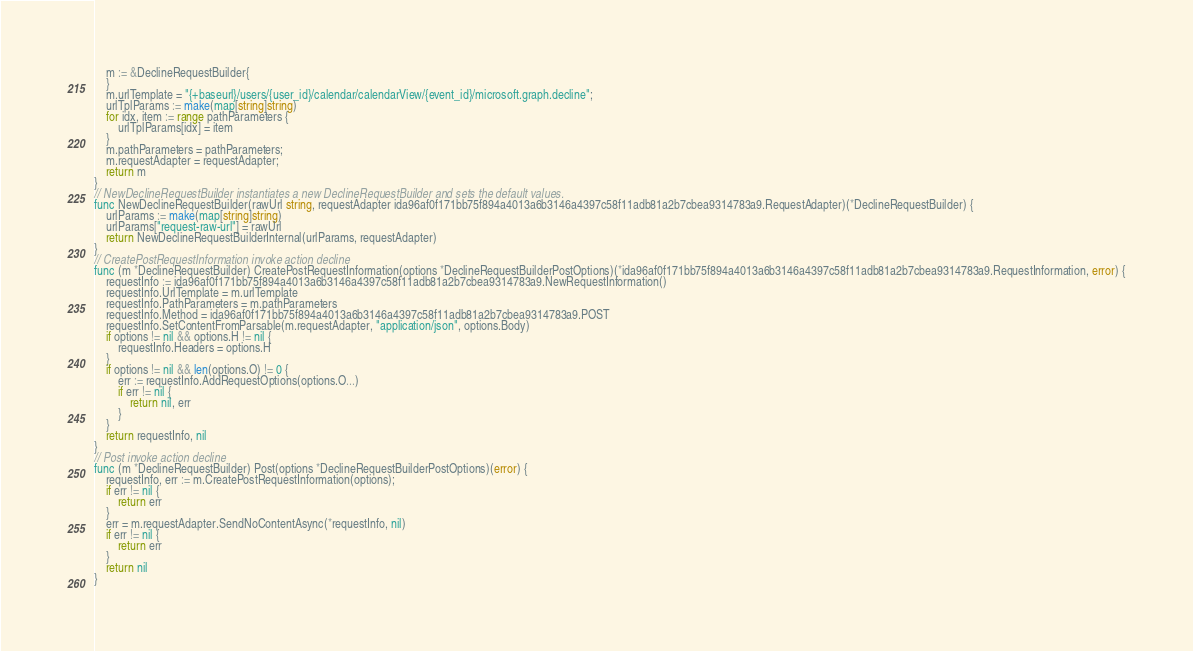Convert code to text. <code><loc_0><loc_0><loc_500><loc_500><_Go_>    m := &DeclineRequestBuilder{
    }
    m.urlTemplate = "{+baseurl}/users/{user_id}/calendar/calendarView/{event_id}/microsoft.graph.decline";
    urlTplParams := make(map[string]string)
    for idx, item := range pathParameters {
        urlTplParams[idx] = item
    }
    m.pathParameters = pathParameters;
    m.requestAdapter = requestAdapter;
    return m
}
// NewDeclineRequestBuilder instantiates a new DeclineRequestBuilder and sets the default values.
func NewDeclineRequestBuilder(rawUrl string, requestAdapter ida96af0f171bb75f894a4013a6b3146a4397c58f11adb81a2b7cbea9314783a9.RequestAdapter)(*DeclineRequestBuilder) {
    urlParams := make(map[string]string)
    urlParams["request-raw-url"] = rawUrl
    return NewDeclineRequestBuilderInternal(urlParams, requestAdapter)
}
// CreatePostRequestInformation invoke action decline
func (m *DeclineRequestBuilder) CreatePostRequestInformation(options *DeclineRequestBuilderPostOptions)(*ida96af0f171bb75f894a4013a6b3146a4397c58f11adb81a2b7cbea9314783a9.RequestInformation, error) {
    requestInfo := ida96af0f171bb75f894a4013a6b3146a4397c58f11adb81a2b7cbea9314783a9.NewRequestInformation()
    requestInfo.UrlTemplate = m.urlTemplate
    requestInfo.PathParameters = m.pathParameters
    requestInfo.Method = ida96af0f171bb75f894a4013a6b3146a4397c58f11adb81a2b7cbea9314783a9.POST
    requestInfo.SetContentFromParsable(m.requestAdapter, "application/json", options.Body)
    if options != nil && options.H != nil {
        requestInfo.Headers = options.H
    }
    if options != nil && len(options.O) != 0 {
        err := requestInfo.AddRequestOptions(options.O...)
        if err != nil {
            return nil, err
        }
    }
    return requestInfo, nil
}
// Post invoke action decline
func (m *DeclineRequestBuilder) Post(options *DeclineRequestBuilderPostOptions)(error) {
    requestInfo, err := m.CreatePostRequestInformation(options);
    if err != nil {
        return err
    }
    err = m.requestAdapter.SendNoContentAsync(*requestInfo, nil)
    if err != nil {
        return err
    }
    return nil
}
</code> 